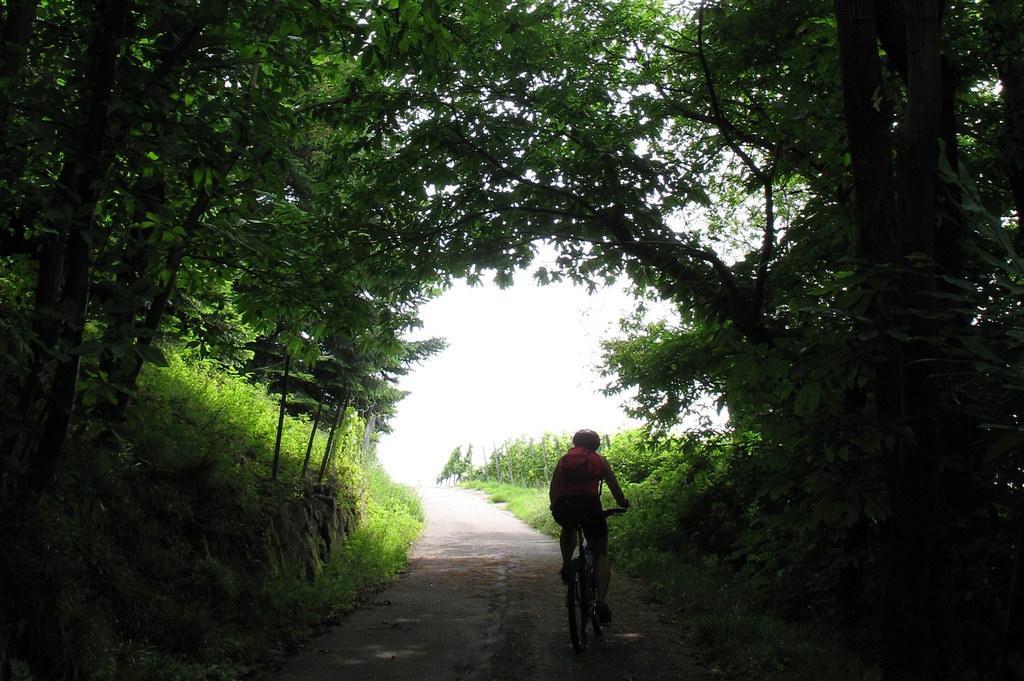In one or two sentences, can you explain what this image depicts? There is a person riding a bicycle on the road. Here we can see grass, plants, and trees. In the background there is sky. 